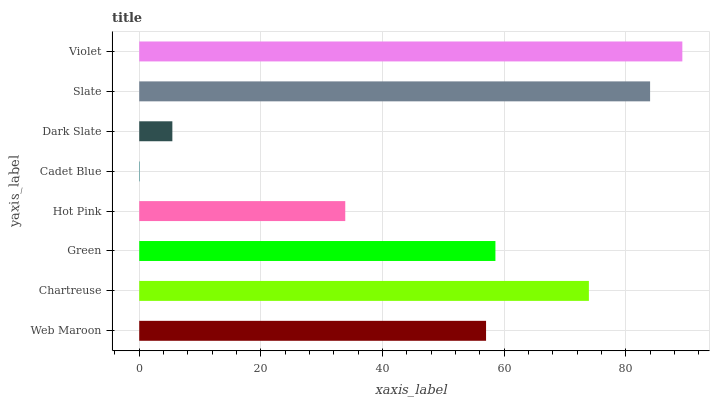Is Cadet Blue the minimum?
Answer yes or no. Yes. Is Violet the maximum?
Answer yes or no. Yes. Is Chartreuse the minimum?
Answer yes or no. No. Is Chartreuse the maximum?
Answer yes or no. No. Is Chartreuse greater than Web Maroon?
Answer yes or no. Yes. Is Web Maroon less than Chartreuse?
Answer yes or no. Yes. Is Web Maroon greater than Chartreuse?
Answer yes or no. No. Is Chartreuse less than Web Maroon?
Answer yes or no. No. Is Green the high median?
Answer yes or no. Yes. Is Web Maroon the low median?
Answer yes or no. Yes. Is Slate the high median?
Answer yes or no. No. Is Dark Slate the low median?
Answer yes or no. No. 